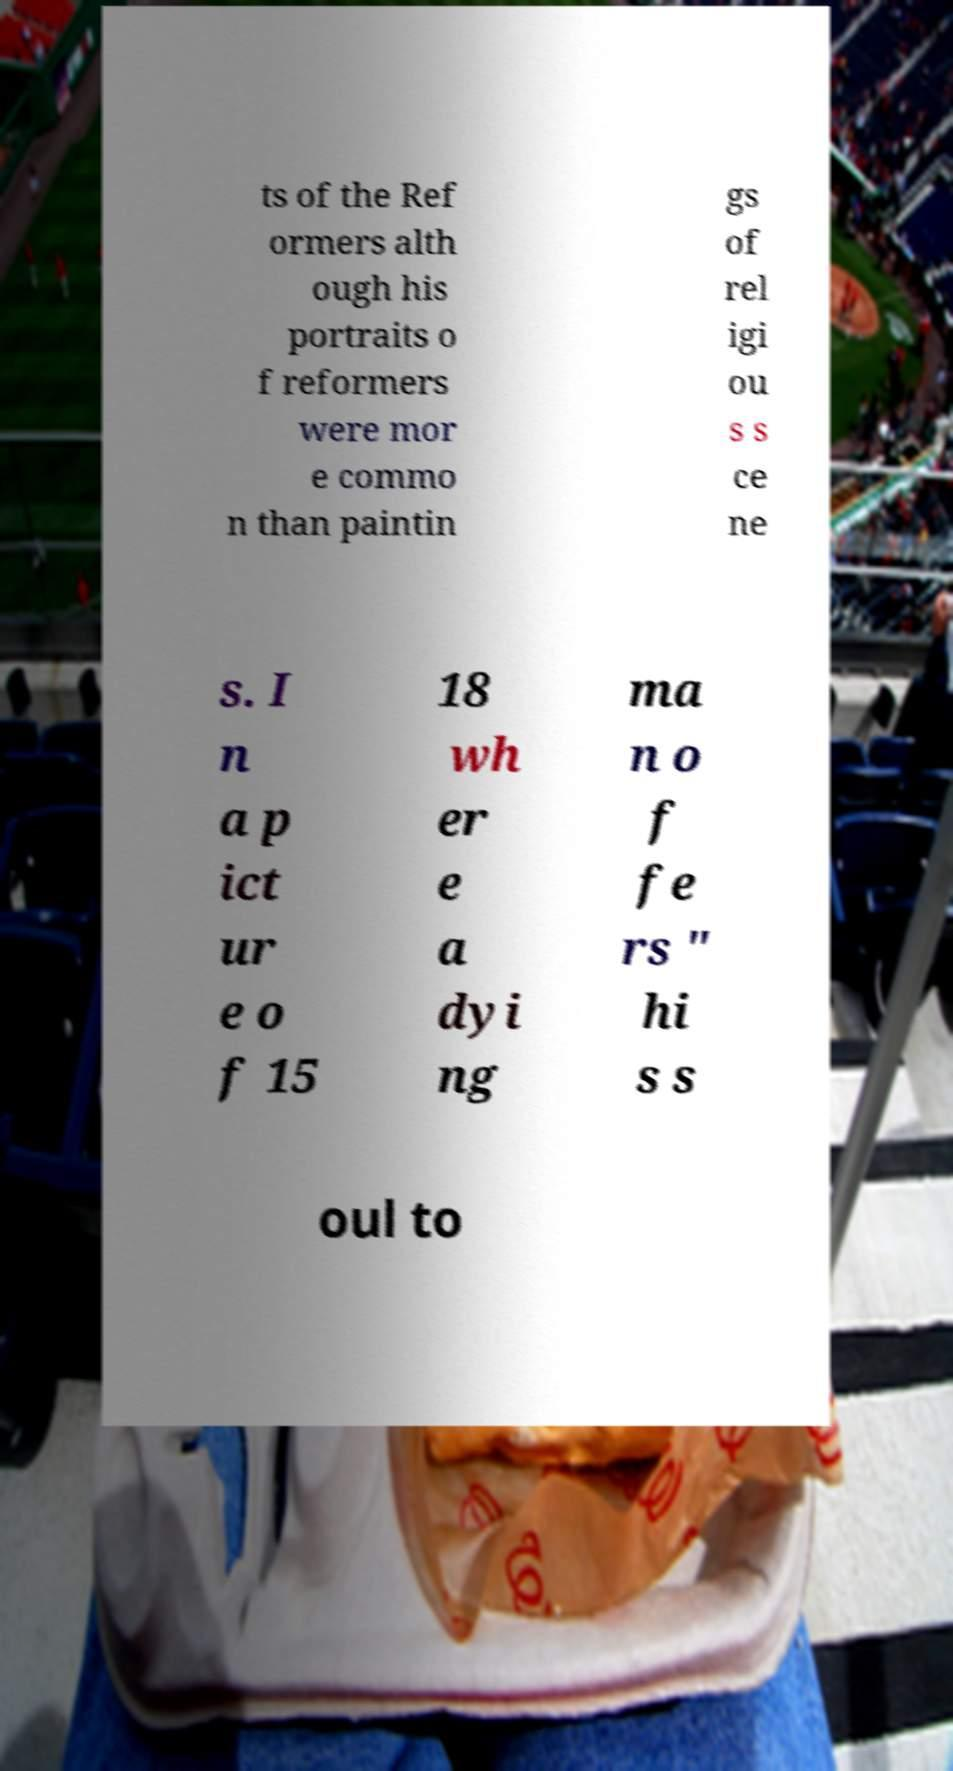Please read and relay the text visible in this image. What does it say? ts of the Ref ormers alth ough his portraits o f reformers were mor e commo n than paintin gs of rel igi ou s s ce ne s. I n a p ict ur e o f 15 18 wh er e a dyi ng ma n o f fe rs " hi s s oul to 